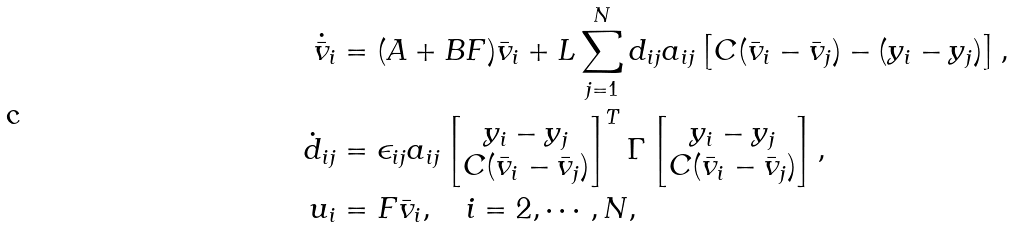<formula> <loc_0><loc_0><loc_500><loc_500>\dot { \bar { v } } _ { i } & = ( A + B F ) \bar { v } _ { i } + L \sum _ { j = 1 } ^ { N } d _ { i j } a _ { i j } \left [ C ( \bar { v } _ { i } - \bar { v } _ { j } ) - ( y _ { i } - y _ { j } ) \right ] , \\ \dot { d } _ { i j } & = \epsilon _ { i j } a _ { i j } \begin{bmatrix} y _ { i } - y _ { j } \\ C ( \bar { v } _ { i } - \bar { v } _ { j } ) \end{bmatrix} ^ { T } \Gamma \begin{bmatrix} y _ { i } - y _ { j } \\ C ( \bar { v } _ { i } - \bar { v } _ { j } ) \end{bmatrix} , \\ u _ { i } & = F \bar { v } _ { i } , \quad i = 2 , \cdots , N ,</formula> 